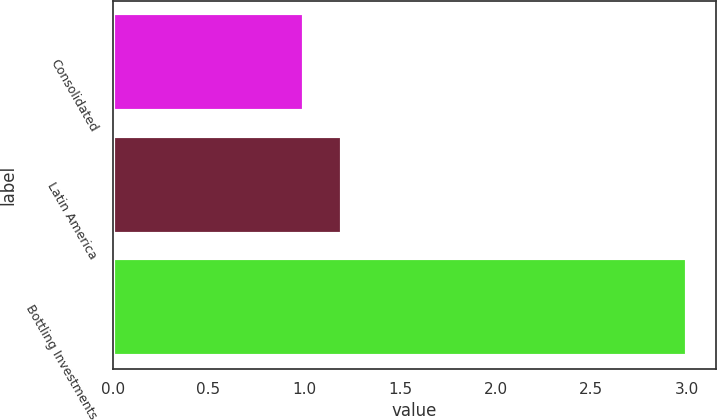Convert chart. <chart><loc_0><loc_0><loc_500><loc_500><bar_chart><fcel>Consolidated<fcel>Latin America<fcel>Bottling Investments<nl><fcel>1<fcel>1.2<fcel>3<nl></chart> 